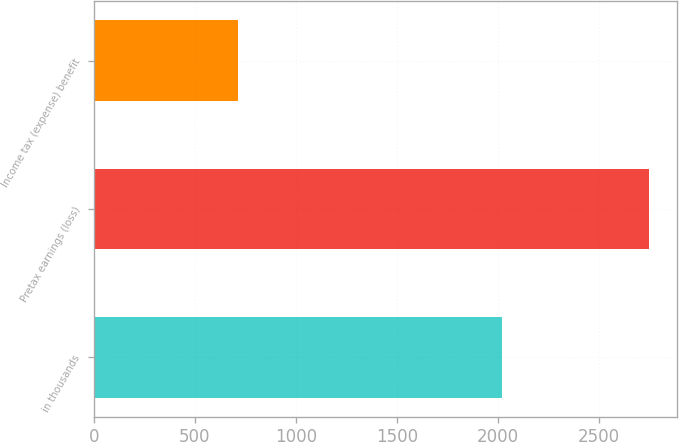Convert chart. <chart><loc_0><loc_0><loc_500><loc_500><bar_chart><fcel>in thousands<fcel>Pretax earnings (loss)<fcel>Income tax (expense) benefit<nl><fcel>2018<fcel>2748<fcel>712<nl></chart> 